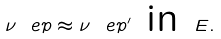<formula> <loc_0><loc_0><loc_500><loc_500>\nu _ { \ } e p \approx \nu _ { \ } e p ^ { \prime } \text { in } E .</formula> 